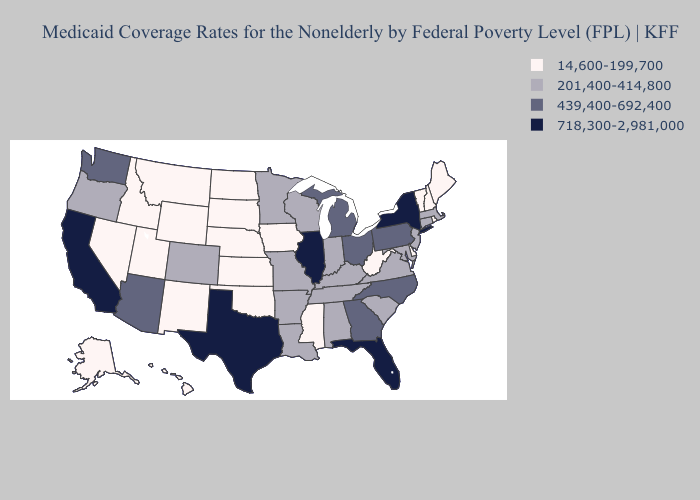Which states hav the highest value in the Northeast?
Concise answer only. New York. Does New York have the lowest value in the Northeast?
Write a very short answer. No. What is the highest value in the MidWest ?
Write a very short answer. 718,300-2,981,000. Which states have the highest value in the USA?
Write a very short answer. California, Florida, Illinois, New York, Texas. What is the highest value in the USA?
Keep it brief. 718,300-2,981,000. How many symbols are there in the legend?
Be succinct. 4. What is the value of Maine?
Answer briefly. 14,600-199,700. What is the value of Utah?
Be succinct. 14,600-199,700. What is the value of Hawaii?
Keep it brief. 14,600-199,700. Which states hav the highest value in the MidWest?
Quick response, please. Illinois. What is the lowest value in the USA?
Give a very brief answer. 14,600-199,700. Does the map have missing data?
Give a very brief answer. No. Name the states that have a value in the range 718,300-2,981,000?
Be succinct. California, Florida, Illinois, New York, Texas. Among the states that border Nevada , does Oregon have the lowest value?
Concise answer only. No. Among the states that border Illinois , which have the lowest value?
Short answer required. Iowa. 